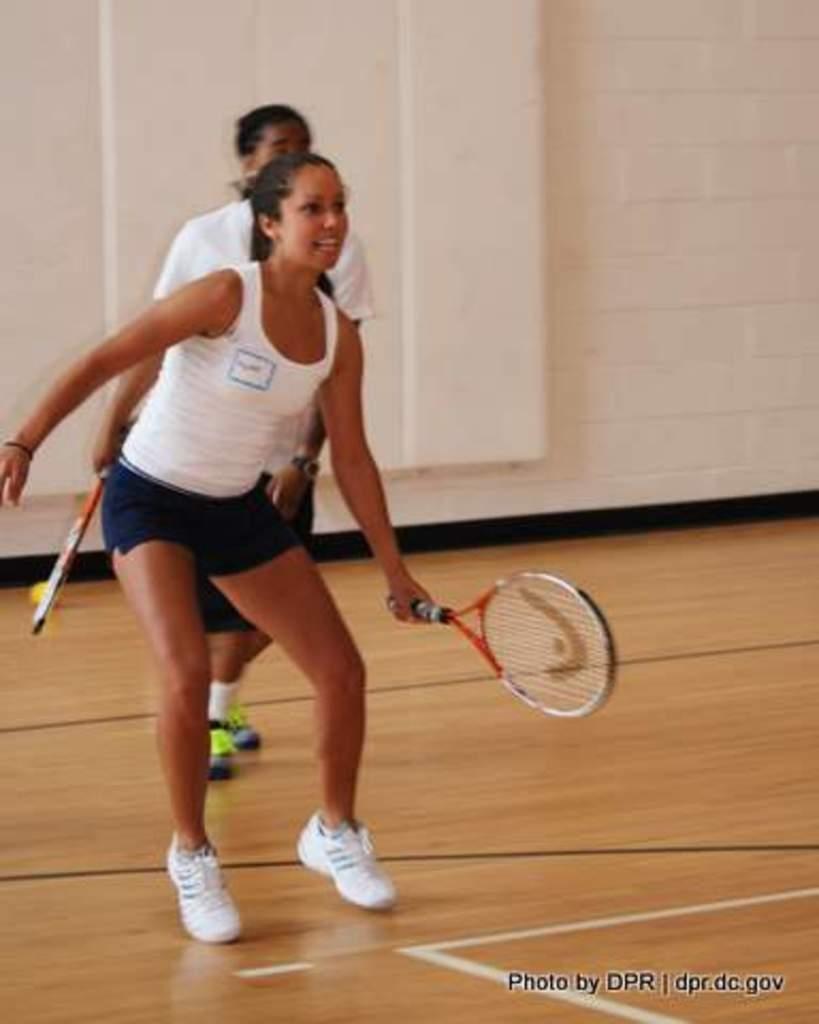How would you summarize this image in a sentence or two? This image is clicked in a tennis court. There are two women in this image. In the front, the woman is holding a tennis racket and wearing a white shirt. In the background there is a wall in white color. 